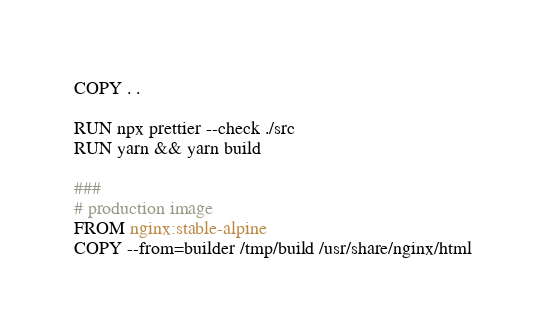Convert code to text. <code><loc_0><loc_0><loc_500><loc_500><_Dockerfile_>COPY . .

RUN npx prettier --check ./src
RUN yarn && yarn build

###
# production image
FROM nginx:stable-alpine
COPY --from=builder /tmp/build /usr/share/nginx/html
</code> 